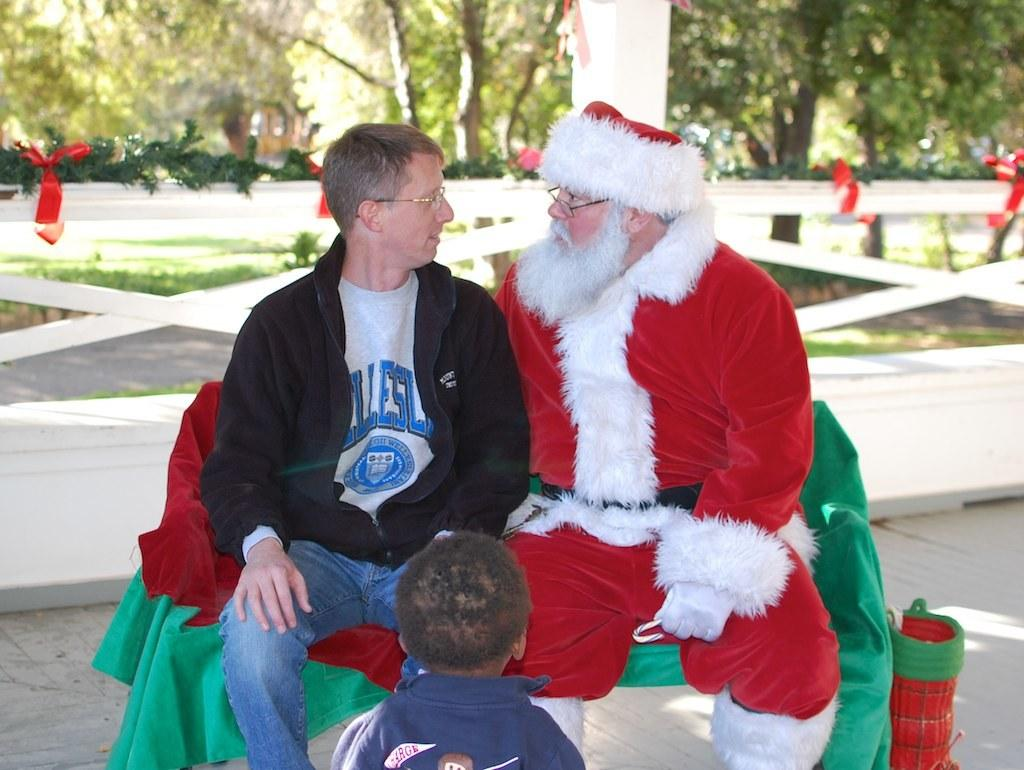How many people are sitting on the bench in the image? There are two people sitting on a bench in the image. What is one person wearing? One person is wearing a Santa dress. What is in front of the two people? There is a boy in front of the two people. Can you describe the background of the image? The background is blurred, and there is a fence and trees visible in the background. What type of road can be seen in the background of the image? There is no road visible in the background of the image; it features a blurred background with a fence and trees. 